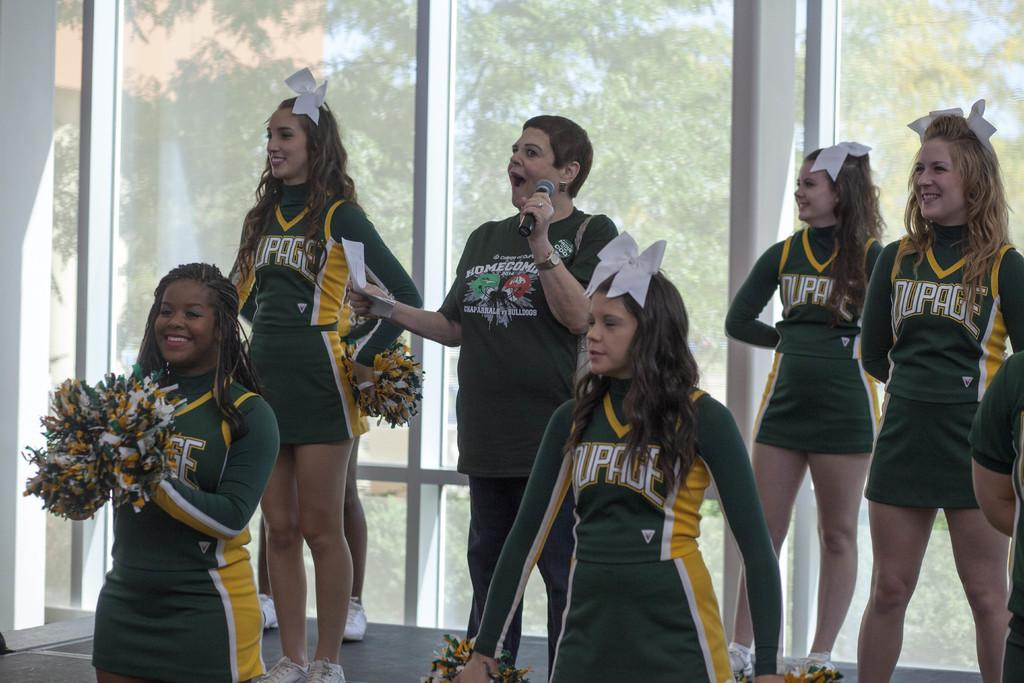<image>
Write a terse but informative summary of the picture. A bunch of cheerleaders with a slogan that ends in the word e on their chest 